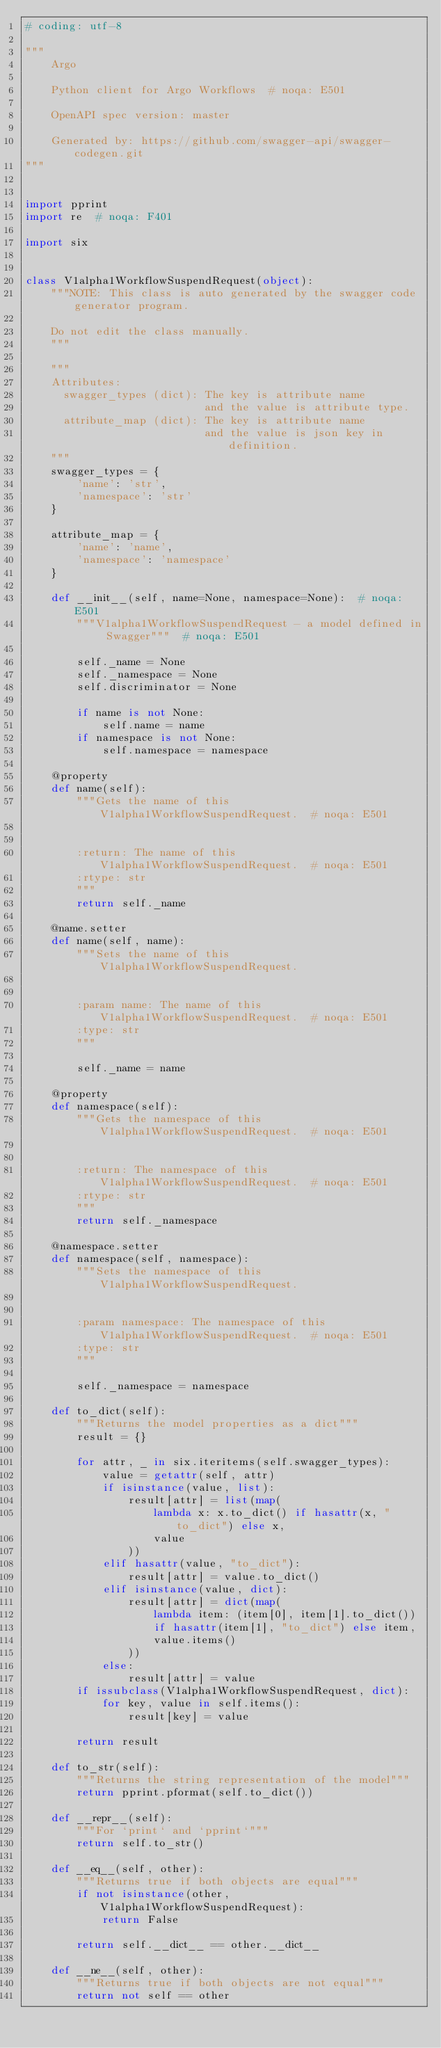Convert code to text. <code><loc_0><loc_0><loc_500><loc_500><_Python_># coding: utf-8

"""
    Argo

    Python client for Argo Workflows  # noqa: E501

    OpenAPI spec version: master
    
    Generated by: https://github.com/swagger-api/swagger-codegen.git
"""


import pprint
import re  # noqa: F401

import six


class V1alpha1WorkflowSuspendRequest(object):
    """NOTE: This class is auto generated by the swagger code generator program.

    Do not edit the class manually.
    """

    """
    Attributes:
      swagger_types (dict): The key is attribute name
                            and the value is attribute type.
      attribute_map (dict): The key is attribute name
                            and the value is json key in definition.
    """
    swagger_types = {
        'name': 'str',
        'namespace': 'str'
    }

    attribute_map = {
        'name': 'name',
        'namespace': 'namespace'
    }

    def __init__(self, name=None, namespace=None):  # noqa: E501
        """V1alpha1WorkflowSuspendRequest - a model defined in Swagger"""  # noqa: E501

        self._name = None
        self._namespace = None
        self.discriminator = None

        if name is not None:
            self.name = name
        if namespace is not None:
            self.namespace = namespace

    @property
    def name(self):
        """Gets the name of this V1alpha1WorkflowSuspendRequest.  # noqa: E501


        :return: The name of this V1alpha1WorkflowSuspendRequest.  # noqa: E501
        :rtype: str
        """
        return self._name

    @name.setter
    def name(self, name):
        """Sets the name of this V1alpha1WorkflowSuspendRequest.


        :param name: The name of this V1alpha1WorkflowSuspendRequest.  # noqa: E501
        :type: str
        """

        self._name = name

    @property
    def namespace(self):
        """Gets the namespace of this V1alpha1WorkflowSuspendRequest.  # noqa: E501


        :return: The namespace of this V1alpha1WorkflowSuspendRequest.  # noqa: E501
        :rtype: str
        """
        return self._namespace

    @namespace.setter
    def namespace(self, namespace):
        """Sets the namespace of this V1alpha1WorkflowSuspendRequest.


        :param namespace: The namespace of this V1alpha1WorkflowSuspendRequest.  # noqa: E501
        :type: str
        """

        self._namespace = namespace

    def to_dict(self):
        """Returns the model properties as a dict"""
        result = {}

        for attr, _ in six.iteritems(self.swagger_types):
            value = getattr(self, attr)
            if isinstance(value, list):
                result[attr] = list(map(
                    lambda x: x.to_dict() if hasattr(x, "to_dict") else x,
                    value
                ))
            elif hasattr(value, "to_dict"):
                result[attr] = value.to_dict()
            elif isinstance(value, dict):
                result[attr] = dict(map(
                    lambda item: (item[0], item[1].to_dict())
                    if hasattr(item[1], "to_dict") else item,
                    value.items()
                ))
            else:
                result[attr] = value
        if issubclass(V1alpha1WorkflowSuspendRequest, dict):
            for key, value in self.items():
                result[key] = value

        return result

    def to_str(self):
        """Returns the string representation of the model"""
        return pprint.pformat(self.to_dict())

    def __repr__(self):
        """For `print` and `pprint`"""
        return self.to_str()

    def __eq__(self, other):
        """Returns true if both objects are equal"""
        if not isinstance(other, V1alpha1WorkflowSuspendRequest):
            return False

        return self.__dict__ == other.__dict__

    def __ne__(self, other):
        """Returns true if both objects are not equal"""
        return not self == other
</code> 